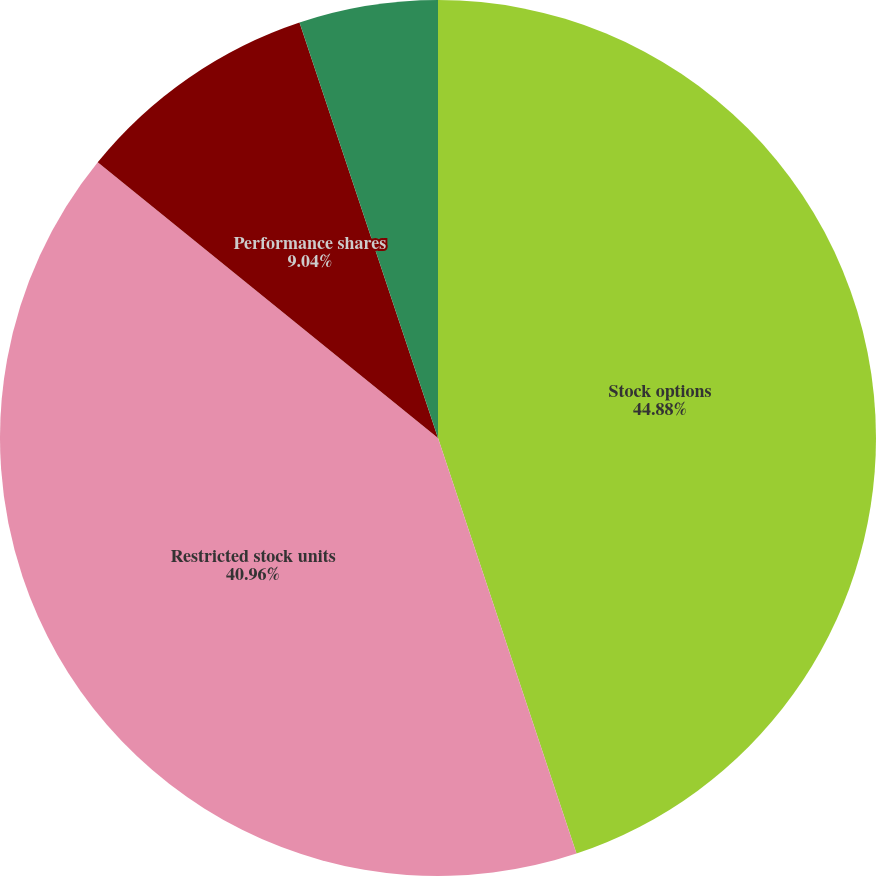Convert chart. <chart><loc_0><loc_0><loc_500><loc_500><pie_chart><fcel>Stock options<fcel>Restricted stock units<fcel>Performance shares<fcel>Other<nl><fcel>44.88%<fcel>40.96%<fcel>9.04%<fcel>5.12%<nl></chart> 